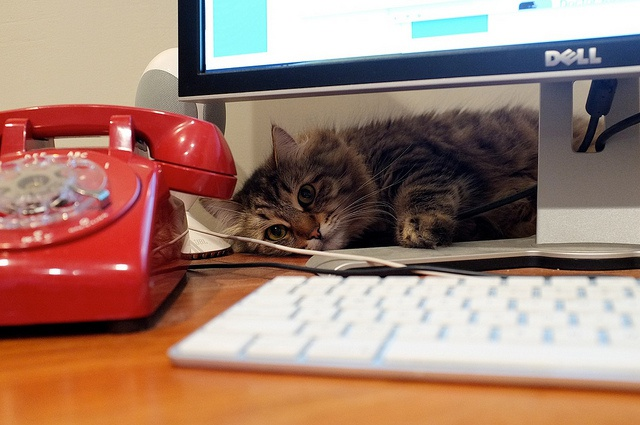Describe the objects in this image and their specific colors. I can see keyboard in tan, lightgray, brown, salmon, and darkgray tones, tv in tan, white, black, navy, and cyan tones, and cat in tan, black, maroon, and gray tones in this image. 